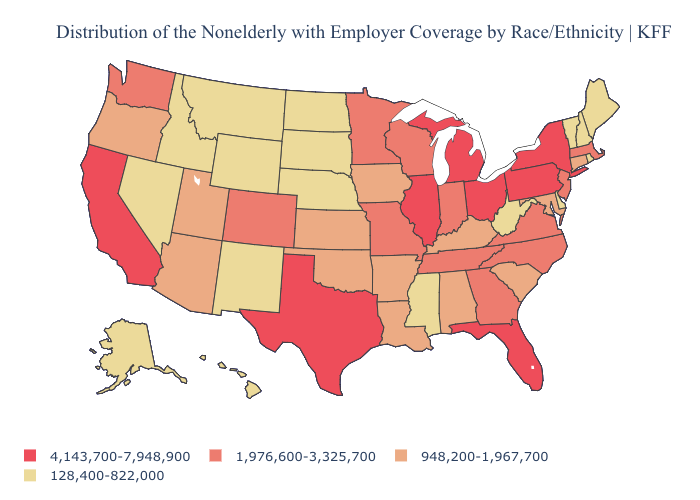Does Massachusetts have the lowest value in the USA?
Be succinct. No. Name the states that have a value in the range 4,143,700-7,948,900?
Write a very short answer. California, Florida, Illinois, Michigan, New York, Ohio, Pennsylvania, Texas. What is the value of New Jersey?
Short answer required. 1,976,600-3,325,700. Is the legend a continuous bar?
Be succinct. No. What is the value of Hawaii?
Write a very short answer. 128,400-822,000. Among the states that border Colorado , which have the lowest value?
Answer briefly. Nebraska, New Mexico, Wyoming. Among the states that border Utah , does Colorado have the highest value?
Answer briefly. Yes. Name the states that have a value in the range 1,976,600-3,325,700?
Short answer required. Colorado, Georgia, Indiana, Massachusetts, Minnesota, Missouri, New Jersey, North Carolina, Tennessee, Virginia, Washington, Wisconsin. What is the value of Illinois?
Short answer required. 4,143,700-7,948,900. Does Pennsylvania have the highest value in the Northeast?
Quick response, please. Yes. What is the lowest value in the South?
Quick response, please. 128,400-822,000. Does South Carolina have the same value as Florida?
Answer briefly. No. Does California have the highest value in the West?
Keep it brief. Yes. Name the states that have a value in the range 1,976,600-3,325,700?
Keep it brief. Colorado, Georgia, Indiana, Massachusetts, Minnesota, Missouri, New Jersey, North Carolina, Tennessee, Virginia, Washington, Wisconsin. 